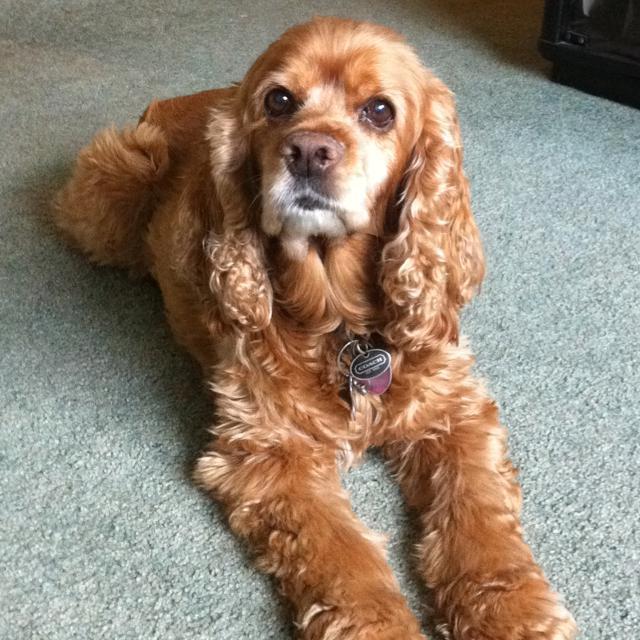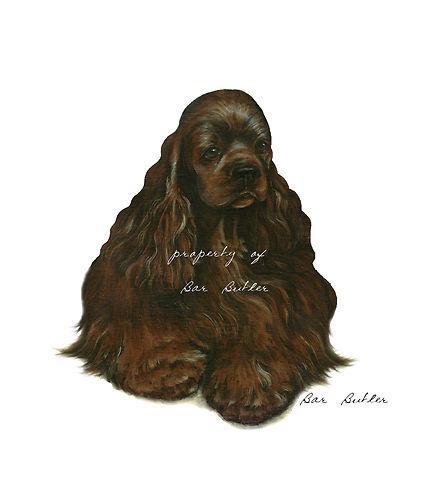The first image is the image on the left, the second image is the image on the right. Analyze the images presented: Is the assertion "One image shows an upright spaniel with bedraggled wet fur, especially on its ears, and the other image shows one spaniel with a coat of dry fur in one color." valid? Answer yes or no. No. The first image is the image on the left, the second image is the image on the right. Evaluate the accuracy of this statement regarding the images: "The dogs in each of the images are situated outside.". Is it true? Answer yes or no. No. 